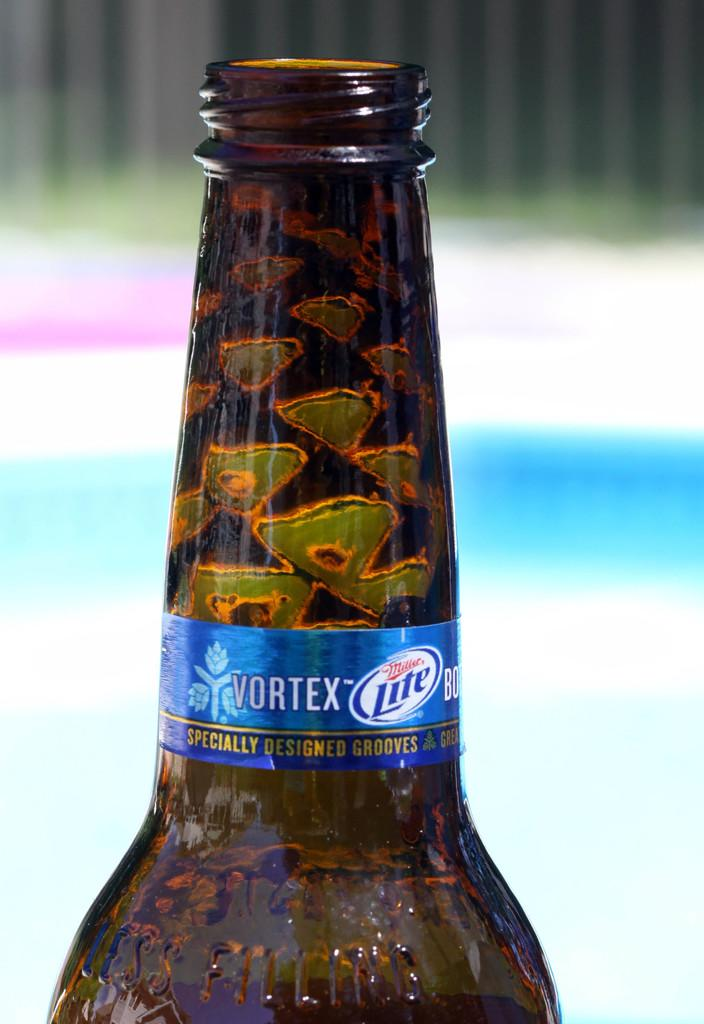<image>
Give a short and clear explanation of the subsequent image. A bottle of beer with a blue Vortex Lite label. 